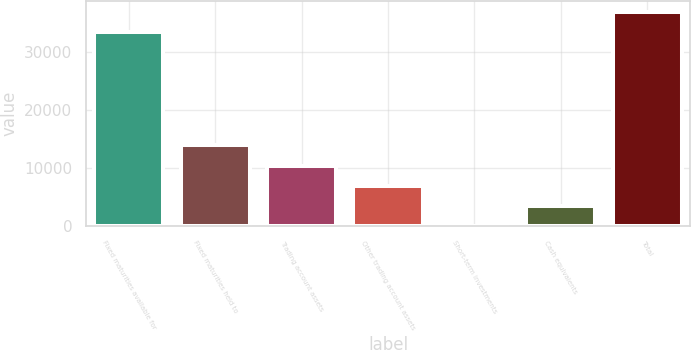Convert chart to OTSL. <chart><loc_0><loc_0><loc_500><loc_500><bar_chart><fcel>Fixed maturities available for<fcel>Fixed maturities held to<fcel>Trading account assets<fcel>Other trading account assets<fcel>Short-term investments<fcel>Cash equivalents<fcel>Total<nl><fcel>33393<fcel>13935.5<fcel>10452.4<fcel>6969.36<fcel>3.2<fcel>3486.28<fcel>36876.1<nl></chart> 